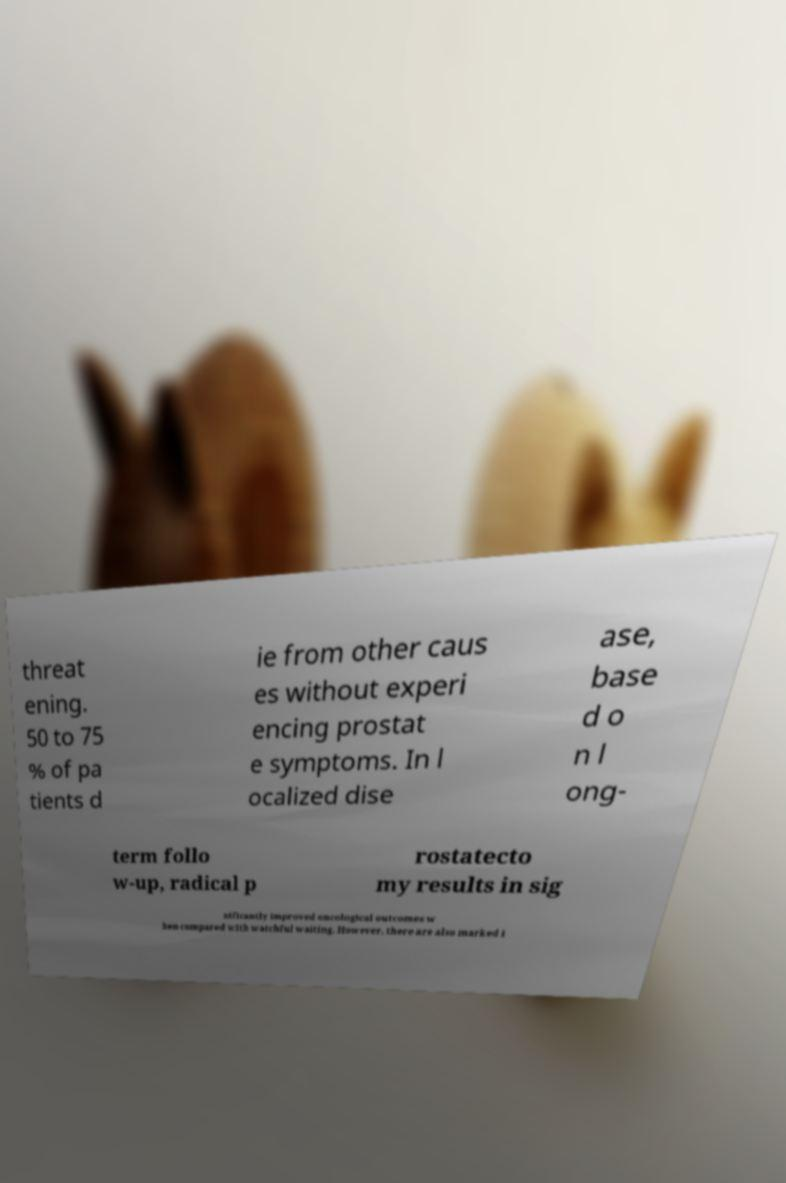Can you accurately transcribe the text from the provided image for me? threat ening. 50 to 75 % of pa tients d ie from other caus es without experi encing prostat e symptoms. In l ocalized dise ase, base d o n l ong- term follo w-up, radical p rostatecto my results in sig nificantly improved oncological outcomes w hen compared with watchful waiting. However, there are also marked i 